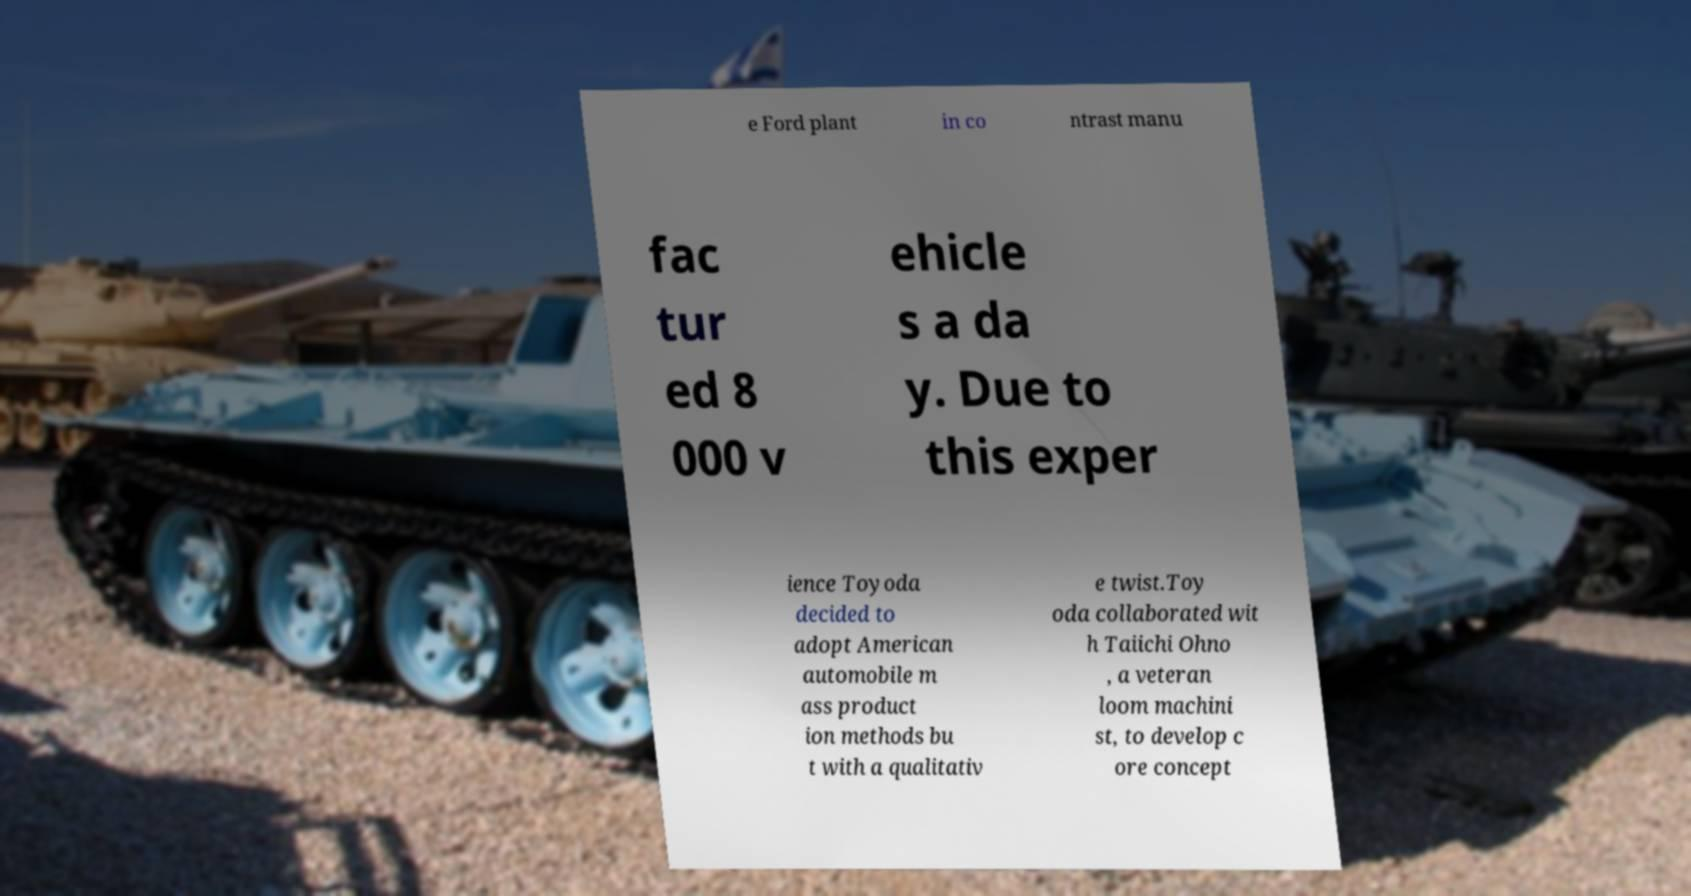I need the written content from this picture converted into text. Can you do that? e Ford plant in co ntrast manu fac tur ed 8 000 v ehicle s a da y. Due to this exper ience Toyoda decided to adopt American automobile m ass product ion methods bu t with a qualitativ e twist.Toy oda collaborated wit h Taiichi Ohno , a veteran loom machini st, to develop c ore concept 